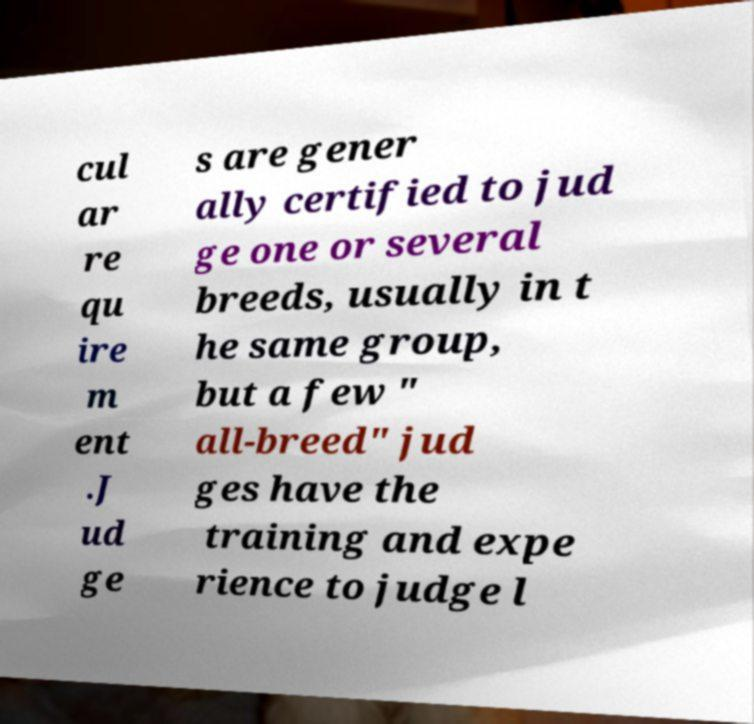Could you assist in decoding the text presented in this image and type it out clearly? cul ar re qu ire m ent .J ud ge s are gener ally certified to jud ge one or several breeds, usually in t he same group, but a few " all-breed" jud ges have the training and expe rience to judge l 